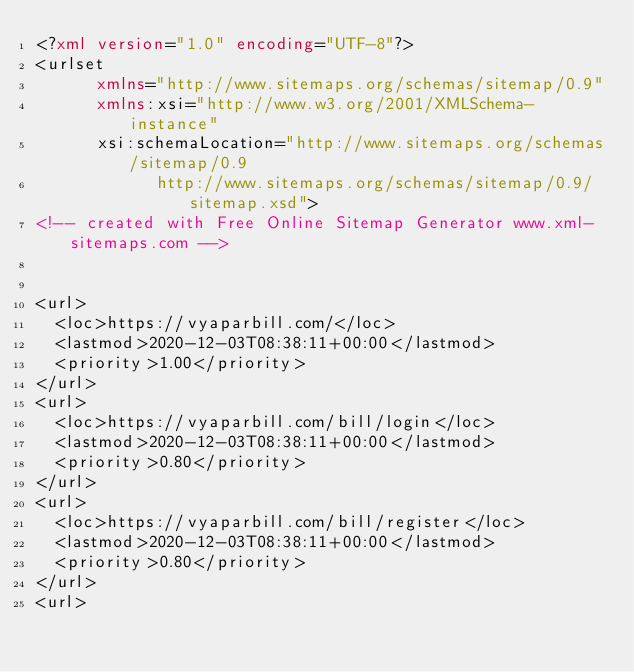Convert code to text. <code><loc_0><loc_0><loc_500><loc_500><_XML_><?xml version="1.0" encoding="UTF-8"?>
<urlset
      xmlns="http://www.sitemaps.org/schemas/sitemap/0.9"
      xmlns:xsi="http://www.w3.org/2001/XMLSchema-instance"
      xsi:schemaLocation="http://www.sitemaps.org/schemas/sitemap/0.9
            http://www.sitemaps.org/schemas/sitemap/0.9/sitemap.xsd">
<!-- created with Free Online Sitemap Generator www.xml-sitemaps.com -->


<url>
  <loc>https://vyaparbill.com/</loc>
  <lastmod>2020-12-03T08:38:11+00:00</lastmod>
  <priority>1.00</priority>
</url>
<url>
  <loc>https://vyaparbill.com/bill/login</loc>
  <lastmod>2020-12-03T08:38:11+00:00</lastmod>
  <priority>0.80</priority>
</url>
<url>
  <loc>https://vyaparbill.com/bill/register</loc>
  <lastmod>2020-12-03T08:38:11+00:00</lastmod>
  <priority>0.80</priority>
</url>
<url></code> 